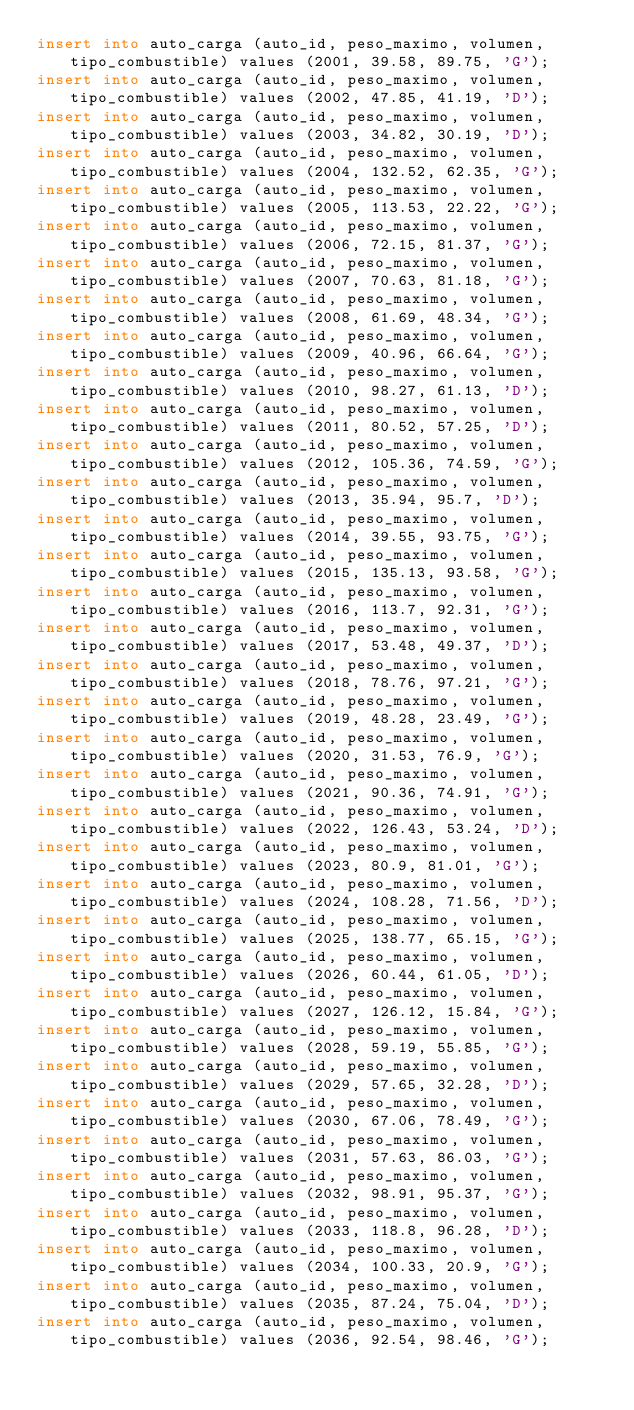Convert code to text. <code><loc_0><loc_0><loc_500><loc_500><_SQL_>insert into auto_carga (auto_id, peso_maximo, volumen, tipo_combustible) values (2001, 39.58, 89.75, 'G');
insert into auto_carga (auto_id, peso_maximo, volumen, tipo_combustible) values (2002, 47.85, 41.19, 'D');
insert into auto_carga (auto_id, peso_maximo, volumen, tipo_combustible) values (2003, 34.82, 30.19, 'D');
insert into auto_carga (auto_id, peso_maximo, volumen, tipo_combustible) values (2004, 132.52, 62.35, 'G');
insert into auto_carga (auto_id, peso_maximo, volumen, tipo_combustible) values (2005, 113.53, 22.22, 'G');
insert into auto_carga (auto_id, peso_maximo, volumen, tipo_combustible) values (2006, 72.15, 81.37, 'G');
insert into auto_carga (auto_id, peso_maximo, volumen, tipo_combustible) values (2007, 70.63, 81.18, 'G');
insert into auto_carga (auto_id, peso_maximo, volumen, tipo_combustible) values (2008, 61.69, 48.34, 'G');
insert into auto_carga (auto_id, peso_maximo, volumen, tipo_combustible) values (2009, 40.96, 66.64, 'G');
insert into auto_carga (auto_id, peso_maximo, volumen, tipo_combustible) values (2010, 98.27, 61.13, 'D');
insert into auto_carga (auto_id, peso_maximo, volumen, tipo_combustible) values (2011, 80.52, 57.25, 'D');
insert into auto_carga (auto_id, peso_maximo, volumen, tipo_combustible) values (2012, 105.36, 74.59, 'G');
insert into auto_carga (auto_id, peso_maximo, volumen, tipo_combustible) values (2013, 35.94, 95.7, 'D');
insert into auto_carga (auto_id, peso_maximo, volumen, tipo_combustible) values (2014, 39.55, 93.75, 'G');
insert into auto_carga (auto_id, peso_maximo, volumen, tipo_combustible) values (2015, 135.13, 93.58, 'G');
insert into auto_carga (auto_id, peso_maximo, volumen, tipo_combustible) values (2016, 113.7, 92.31, 'G');
insert into auto_carga (auto_id, peso_maximo, volumen, tipo_combustible) values (2017, 53.48, 49.37, 'D');
insert into auto_carga (auto_id, peso_maximo, volumen, tipo_combustible) values (2018, 78.76, 97.21, 'G');
insert into auto_carga (auto_id, peso_maximo, volumen, tipo_combustible) values (2019, 48.28, 23.49, 'G');
insert into auto_carga (auto_id, peso_maximo, volumen, tipo_combustible) values (2020, 31.53, 76.9, 'G');
insert into auto_carga (auto_id, peso_maximo, volumen, tipo_combustible) values (2021, 90.36, 74.91, 'G');
insert into auto_carga (auto_id, peso_maximo, volumen, tipo_combustible) values (2022, 126.43, 53.24, 'D');
insert into auto_carga (auto_id, peso_maximo, volumen, tipo_combustible) values (2023, 80.9, 81.01, 'G');
insert into auto_carga (auto_id, peso_maximo, volumen, tipo_combustible) values (2024, 108.28, 71.56, 'D');
insert into auto_carga (auto_id, peso_maximo, volumen, tipo_combustible) values (2025, 138.77, 65.15, 'G');
insert into auto_carga (auto_id, peso_maximo, volumen, tipo_combustible) values (2026, 60.44, 61.05, 'D');
insert into auto_carga (auto_id, peso_maximo, volumen, tipo_combustible) values (2027, 126.12, 15.84, 'G');
insert into auto_carga (auto_id, peso_maximo, volumen, tipo_combustible) values (2028, 59.19, 55.85, 'G');
insert into auto_carga (auto_id, peso_maximo, volumen, tipo_combustible) values (2029, 57.65, 32.28, 'D');
insert into auto_carga (auto_id, peso_maximo, volumen, tipo_combustible) values (2030, 67.06, 78.49, 'G');
insert into auto_carga (auto_id, peso_maximo, volumen, tipo_combustible) values (2031, 57.63, 86.03, 'G');
insert into auto_carga (auto_id, peso_maximo, volumen, tipo_combustible) values (2032, 98.91, 95.37, 'G');
insert into auto_carga (auto_id, peso_maximo, volumen, tipo_combustible) values (2033, 118.8, 96.28, 'D');
insert into auto_carga (auto_id, peso_maximo, volumen, tipo_combustible) values (2034, 100.33, 20.9, 'G');
insert into auto_carga (auto_id, peso_maximo, volumen, tipo_combustible) values (2035, 87.24, 75.04, 'D');
insert into auto_carga (auto_id, peso_maximo, volumen, tipo_combustible) values (2036, 92.54, 98.46, 'G');</code> 